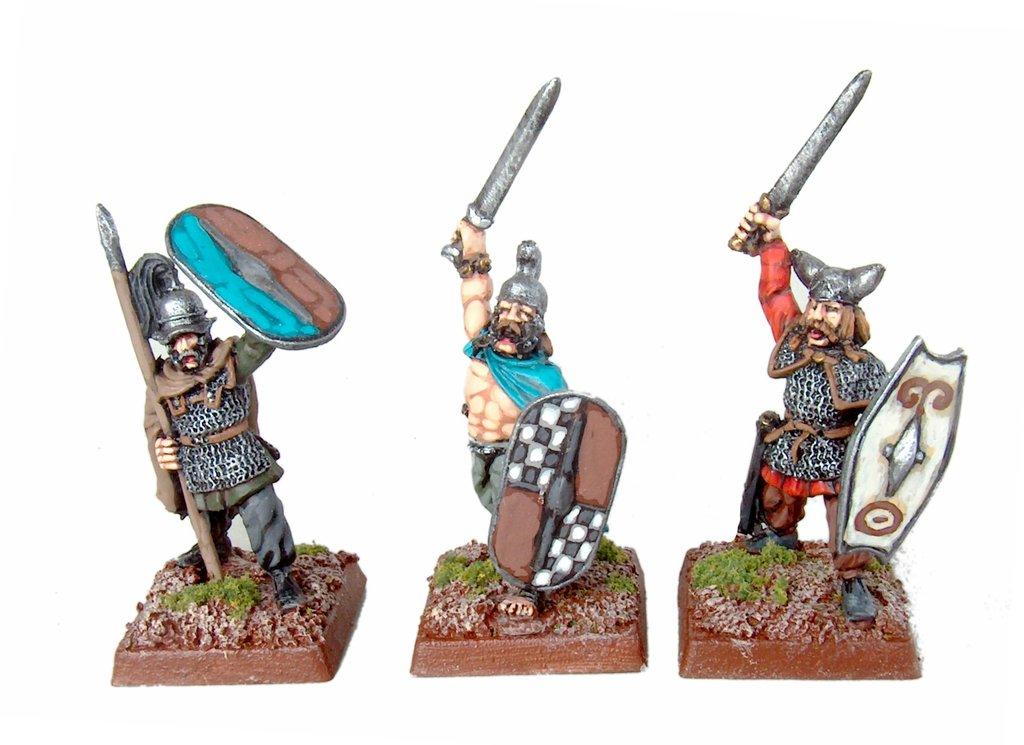What is depicted in the image? There are statues of a person holding weapons in the image. What can be seen in the background of the image? The background of the image is white. What type of monkey can be seen attempting to cook in the image? There is no monkey or cooking activity present in the image. 